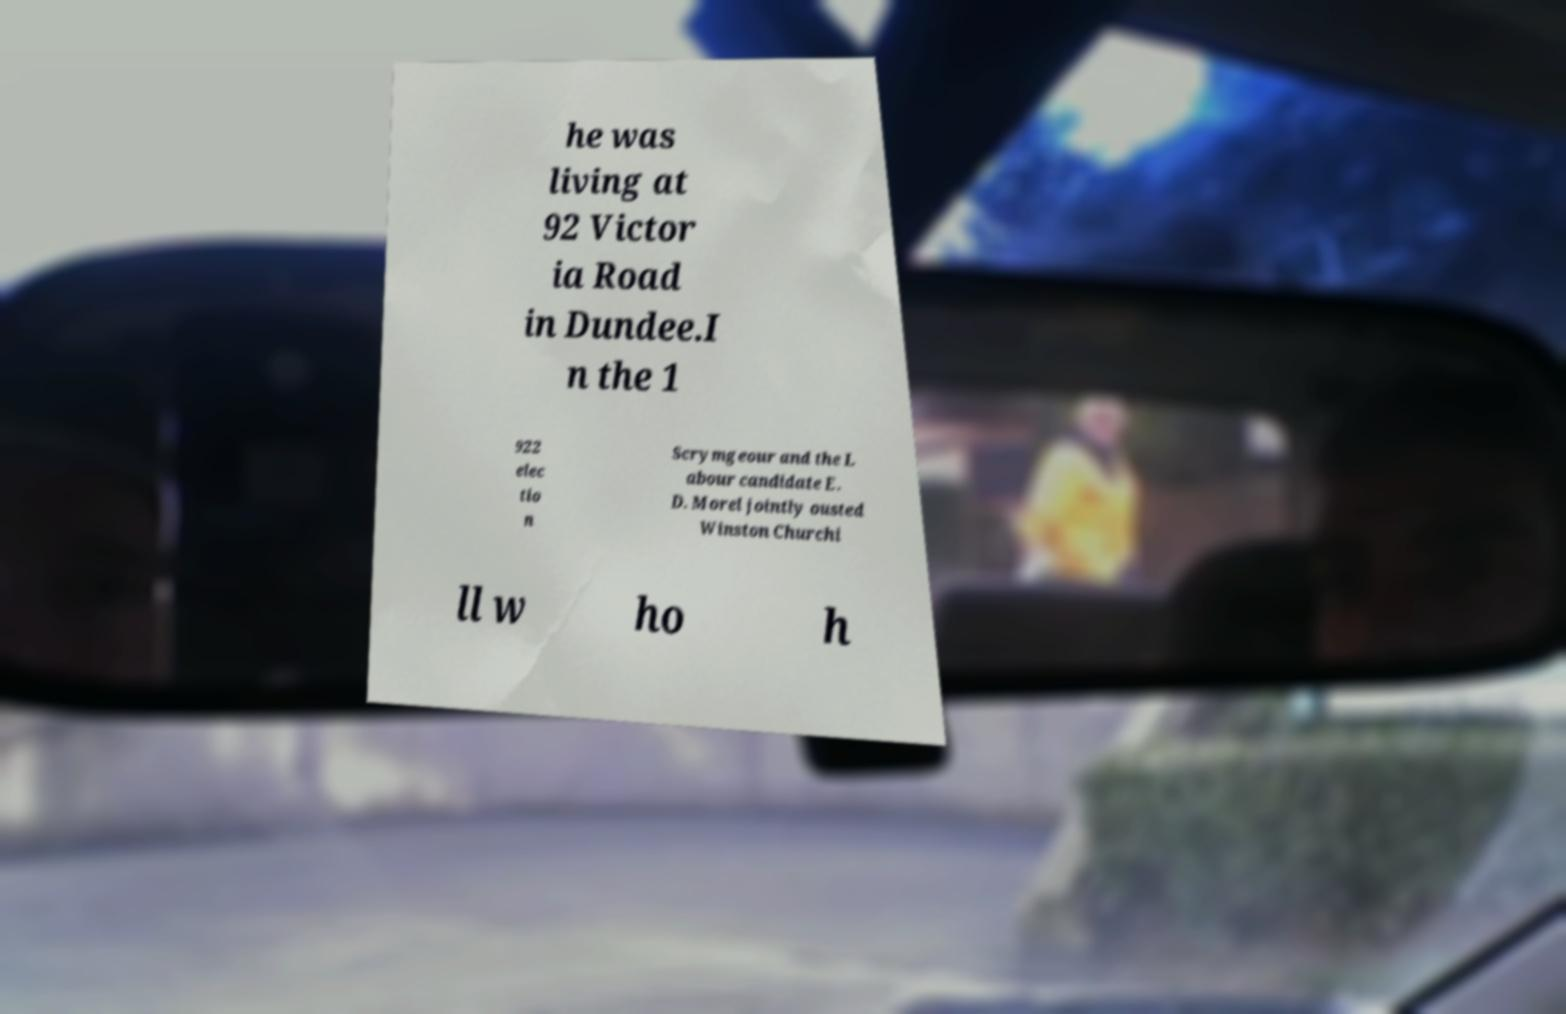Can you read and provide the text displayed in the image?This photo seems to have some interesting text. Can you extract and type it out for me? he was living at 92 Victor ia Road in Dundee.I n the 1 922 elec tio n Scrymgeour and the L abour candidate E. D. Morel jointly ousted Winston Churchi ll w ho h 